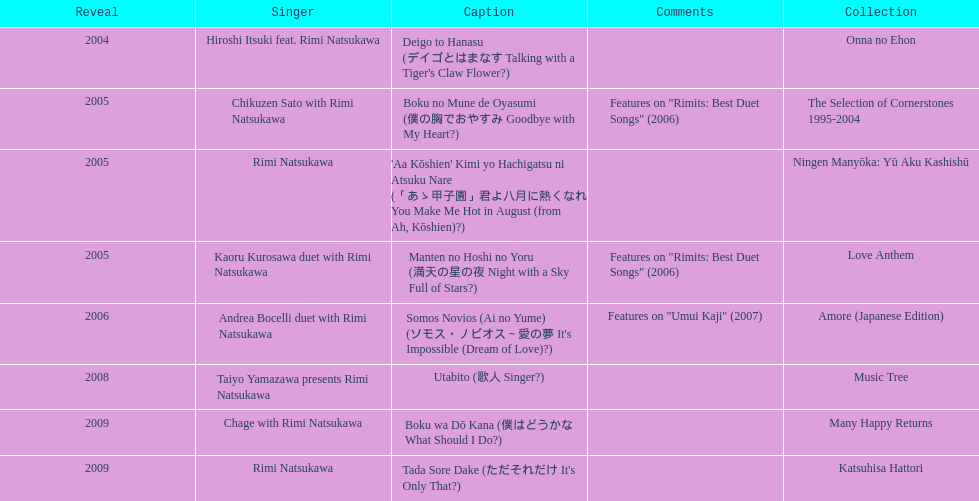During 2005, in how many events did this artist participate other than this one? 3. 